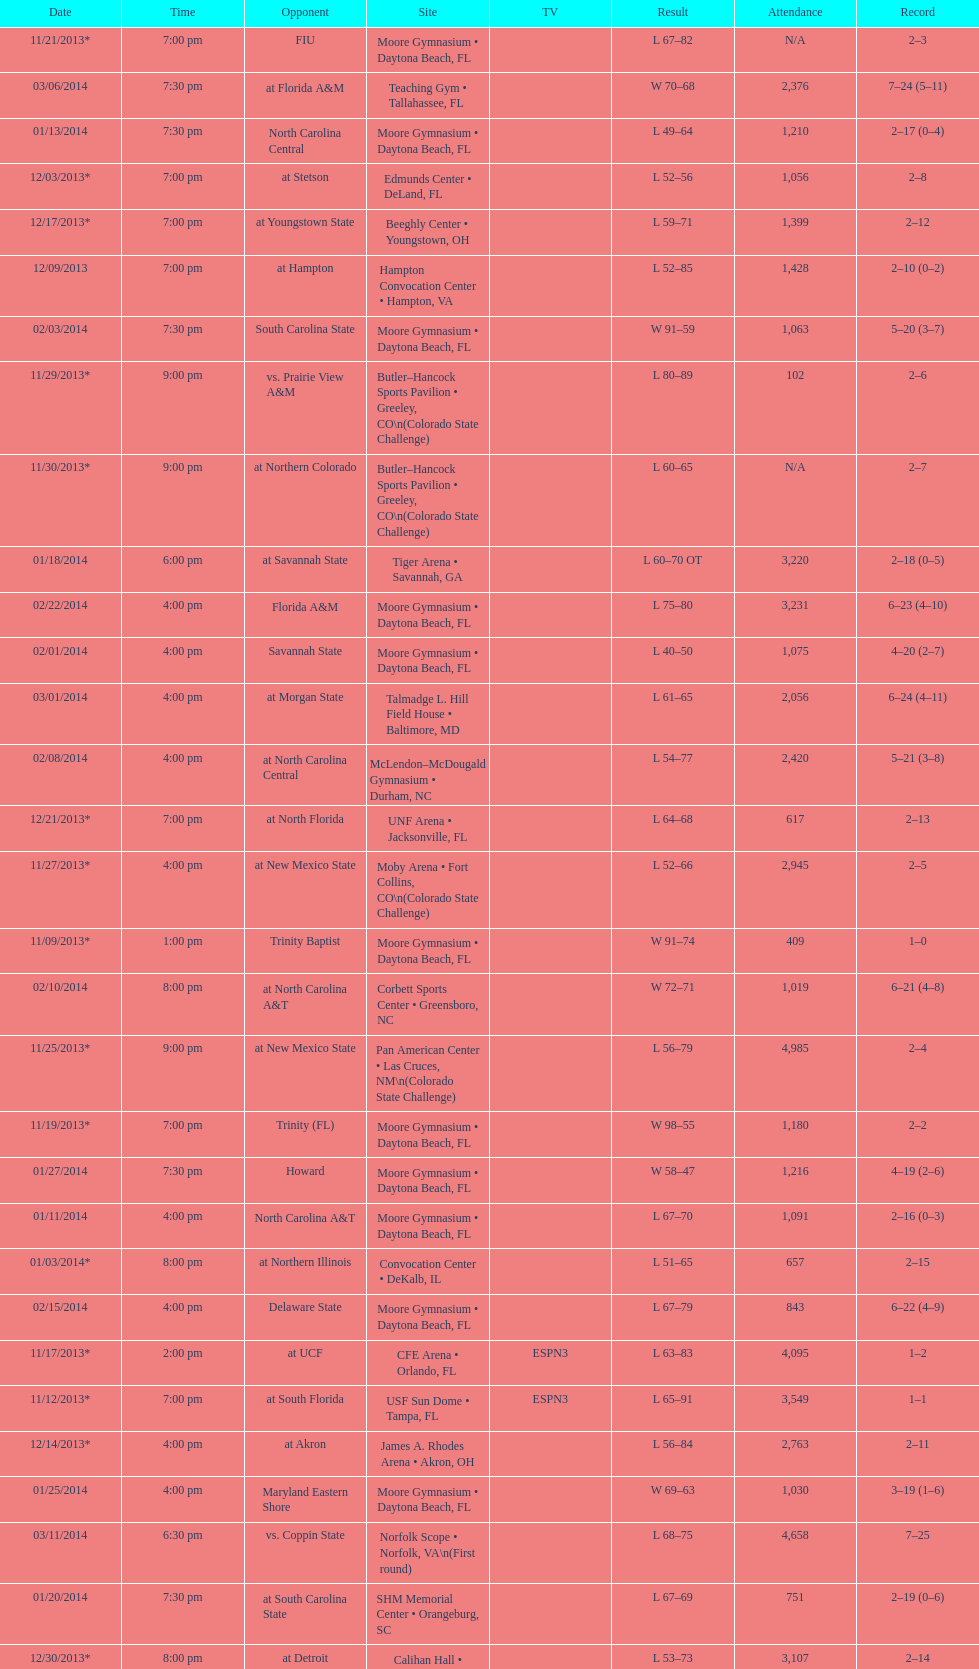Which game was later at night, fiu or northern colorado? Northern Colorado. 